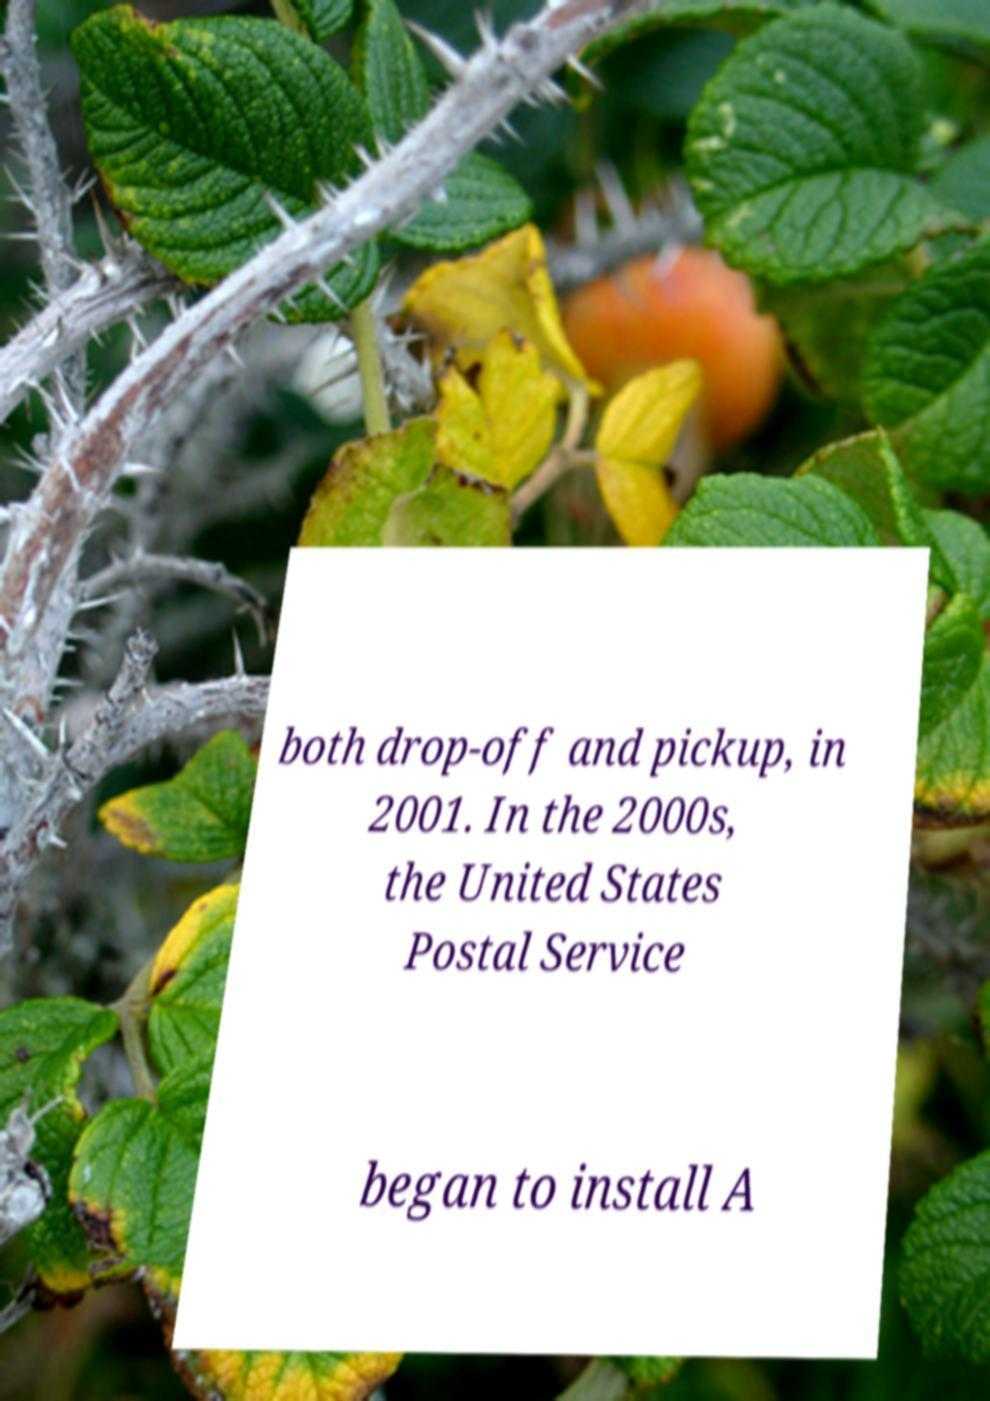Please read and relay the text visible in this image. What does it say? both drop-off and pickup, in 2001. In the 2000s, the United States Postal Service began to install A 